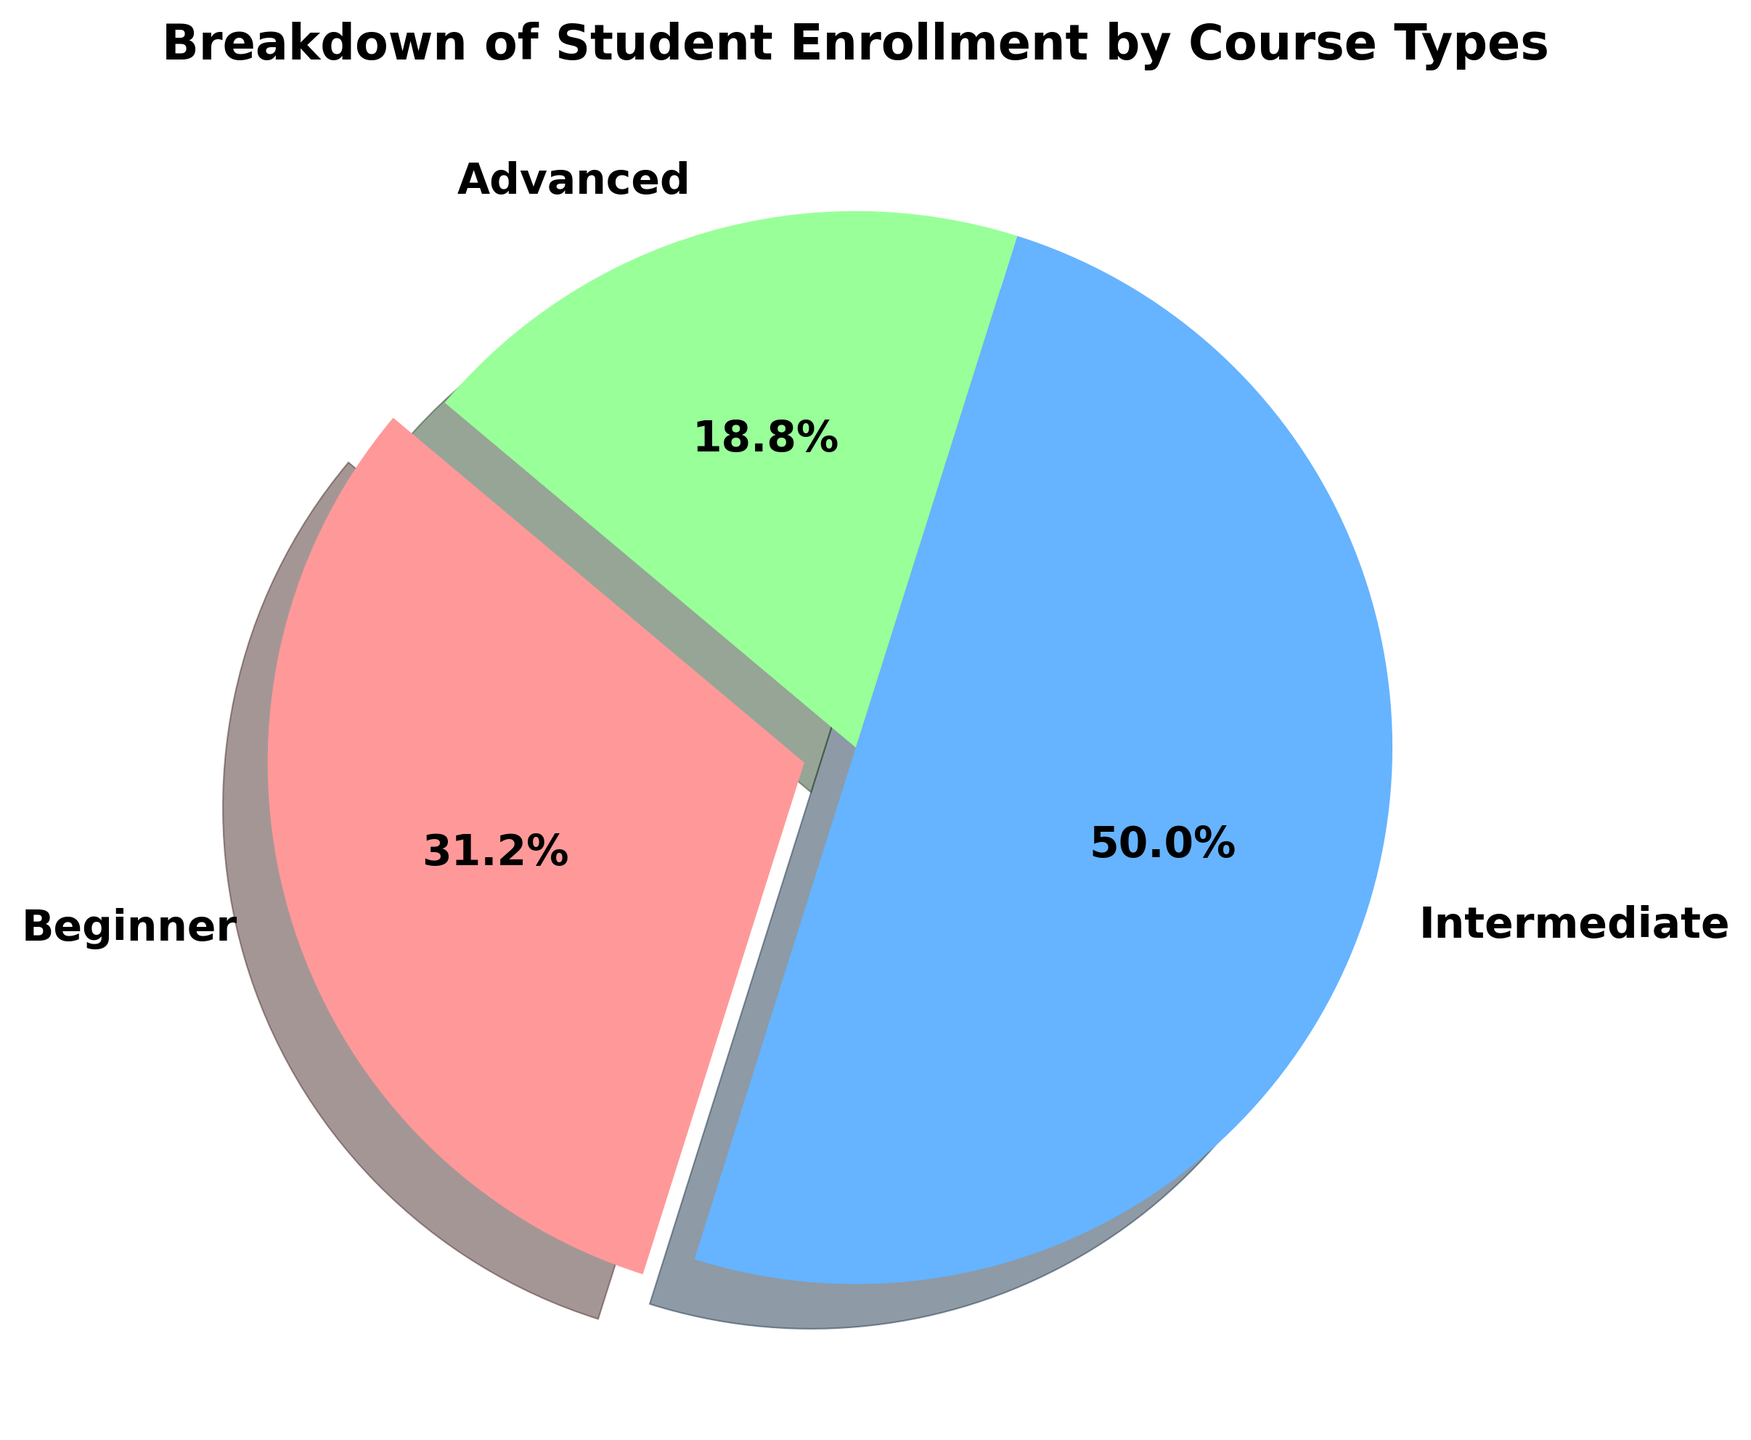What percentage of students are enrolled in Beginner courses? To find the percentage of students enrolled in Beginner courses, refer to the pie chart's labels and percentages. The Beginner segment, which is separated with an exploded slice, shows a detailed percentage.
Answer: 31.2% Which course type has the highest enrollment? By visually assessing the pie chart, the segment with the largest area represents the course type with the highest enrollment. The Intermediate course occupies the most extensive slice of the pie chart.
Answer: Intermediate How many more students are enrolled in Intermediate courses compared to Advanced courses? From the chart, we know the enrollments: Intermediate (4000), Advanced (1500). Subtract Advanced from Intermediate (4000 - 1500) to get the difference.
Answer: 2500 What is the total number of students enrolled across all courses? Sum the enrollments for all course types listed in the pie chart: Beginner (2500), Intermediate (4000), Advanced (1500). The total is 2500 + 4000 + 1500.
Answer: 8000 What proportion of students enrolled in Advanced courses out of the total enrollment? Divide the number of Advanced course enrollments by the total number of enrollments. The calculation is 1500 / 8000, then multiply by 100 to get the percentage.
Answer: 18.8% Compare the enrollments in Beginner and Advanced courses: which has fewer students and by how many? Subtract the number of students enrolled in Advanced courses from Beginner courses using the figures from the pie chart. Beginner has 2500 students and Advanced has 1500, thus 2500 - 1500.
Answer: Advanced, by 1000 If we combine Beginner and Advanced enrollments, what percentage of the total enrollment does this combined group represent? Add Beginner (2500) and Advanced (1500) enrollments to get a combined total, then divide by the overall total enrollment. The calculation is (2500 + 1500) / 8000, times 100 for the percentage.
Answer: 50% Which color represents the Intermediate courses, and what does its size indicate about its prominence? By examining the visual attributes of the chart, Intermediate courses are represented by the largest slice, which is colored blue. The slice size indicates it has the most significant student enrollment.
Answer: Blue, highest proportion If every slice is equally sized, what would be the expected enrollment for each course type given the total number of students? Divide the total enrollment by three, since there are three course types. The total enrollment is 8000, so 8000 / 3.
Answer: 2667 students Compare the sizes of the Beginner and Intermediate course slices: which one is larger and what does this imply about their enrollment differences? The Intermediate slice is larger than the Beginner slice. This visual difference signifies that more students are enrolled in Intermediate courses than in Beginner courses.
Answer: Intermediate, more enrollees 